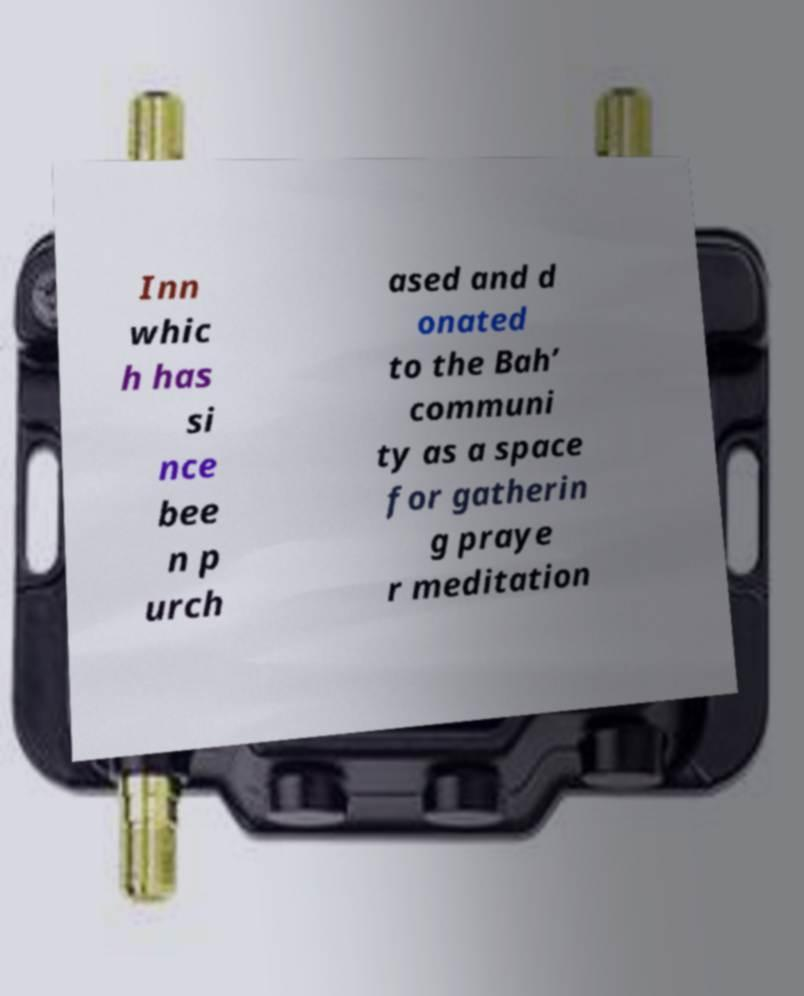For documentation purposes, I need the text within this image transcribed. Could you provide that? Inn whic h has si nce bee n p urch ased and d onated to the Bah’ communi ty as a space for gatherin g praye r meditation 